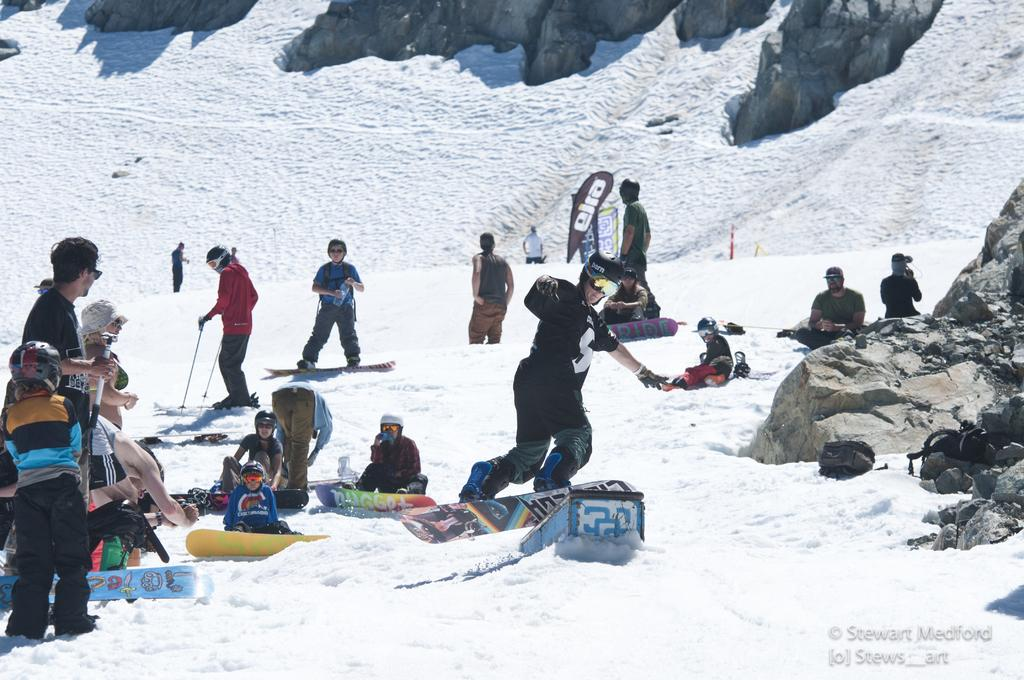How many people are in the image? There are many people in the image. What are some people doing in the image? Some people are sitting on the ground, while others are skiing. What can be seen in the background of the image? There are hills in the background of the image. What is the condition of the ground in the image? There is snow on the ground. What type of guitar can be seen being played in the image? There is no guitar present in the image; the people are skiing and sitting on the ground. Is there a hospital visible in the image? No, there is no hospital present in the image; the focus is on the people and the snowy environment. 